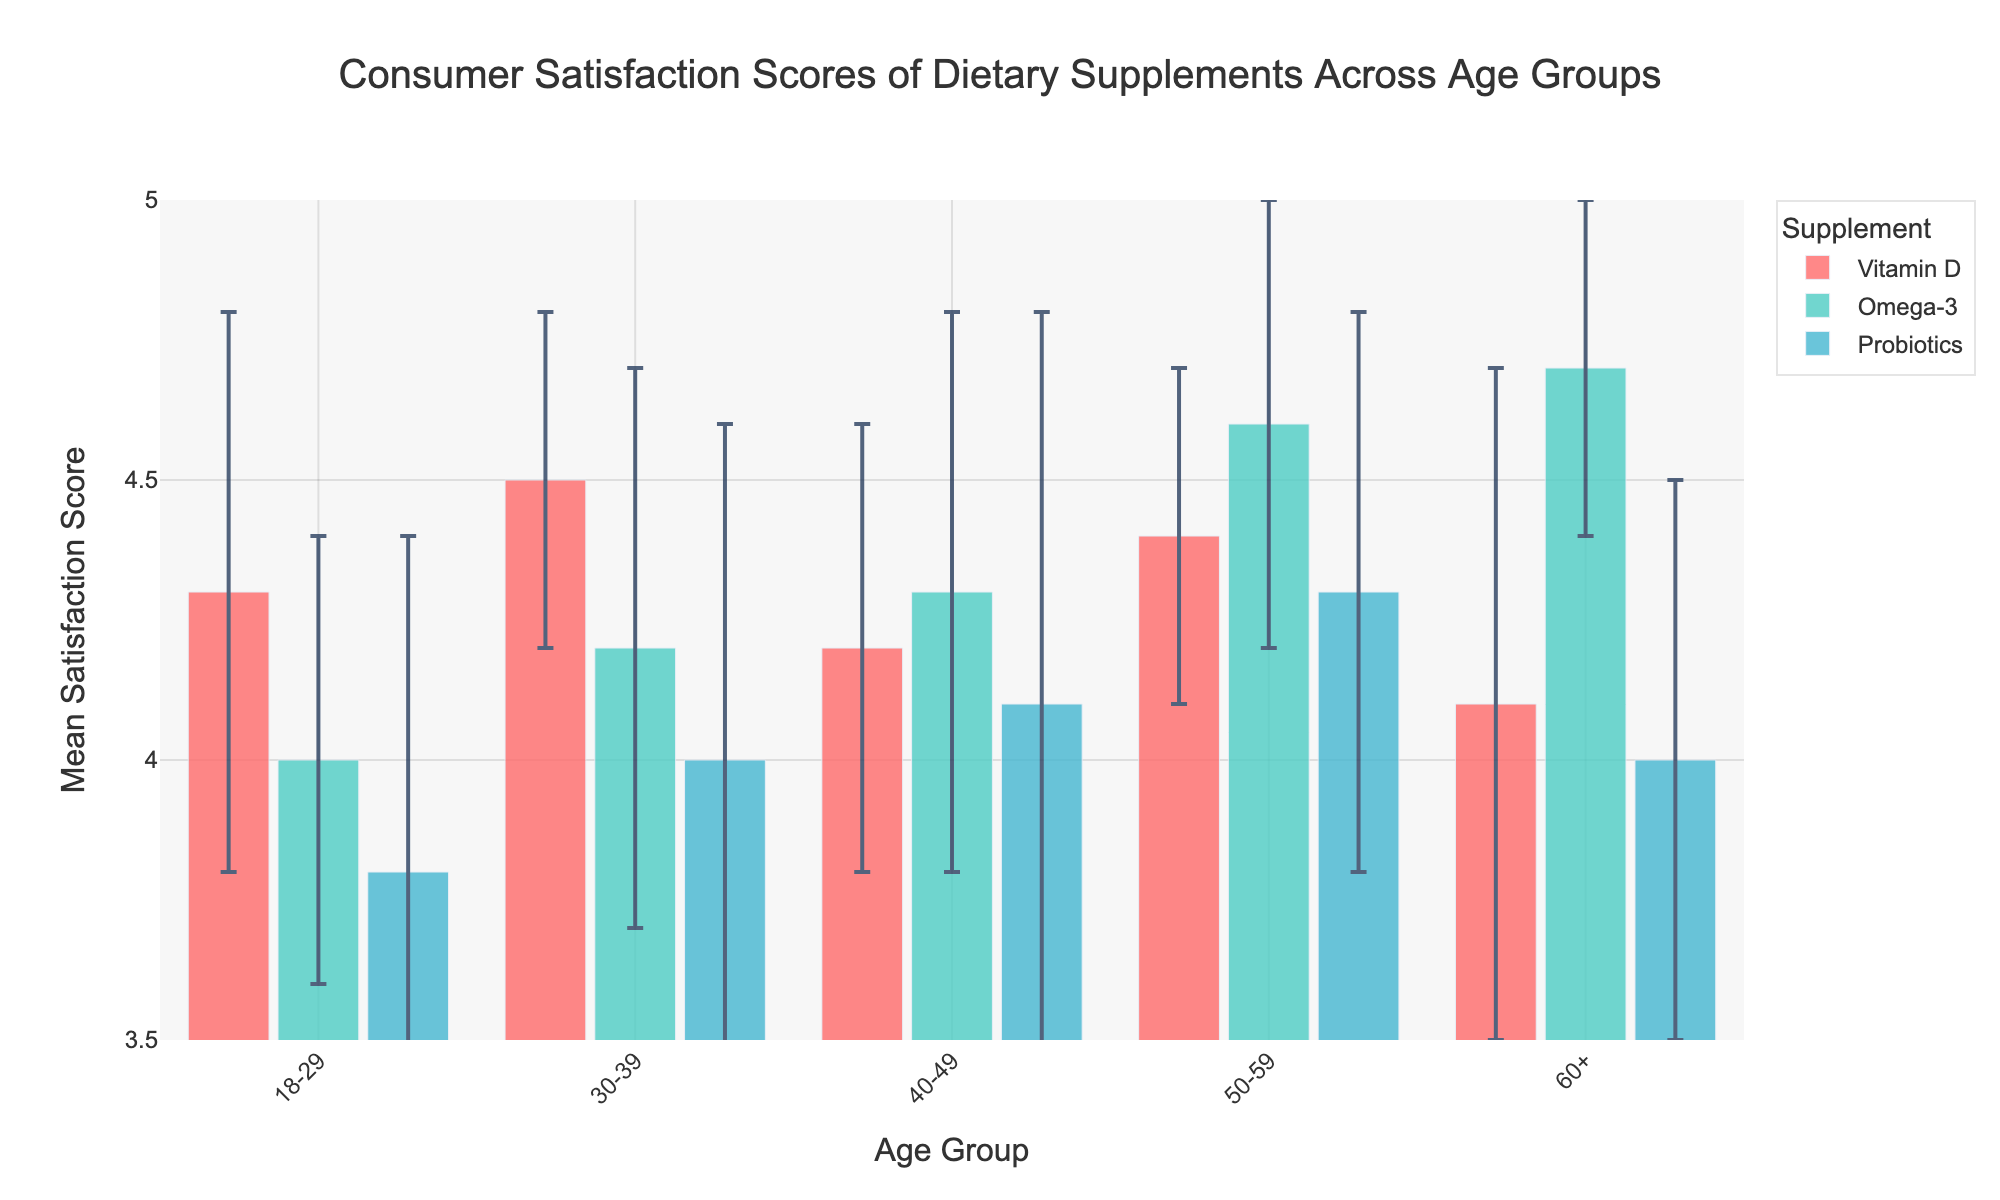What is the title of the figure? The title is displayed prominently at the top of the figure in larger font size. It summarizes the data presented in the plot.
Answer: Consumer Satisfaction Scores of Dietary Supplements Across Age Groups Which age group has the highest mean satisfaction score for Omega-3 supplements? The mean satisfaction scores for Omega-3 supplements are visible on the bars corresponding to each age group. The highest mean satisfaction score for Omega-3 is 4.7 in the 60+ age group.
Answer: 60+ What is the range of mean satisfaction scores for Vitamin D supplements? The range can be computed by finding the difference between the highest and lowest mean satisfaction scores for Vitamin D. The highest score is 4.5 in the 30-39 age group, and the lowest score is 4.1 in the 60+ age group, so the range is 4.5 - 4.1.
Answer: 0.4 Which age group exhibits the least variability in satisfaction scores for all supplements? Variability can be inferred from the standard deviations shown as error bars. The smallest error bars indicate the least variability. By comparing the error bars across all supplements, the 30-39 age group generally has the smallest error bars.
Answer: 30-39 How do the satisfaction scores for Probiotics vary across age groups? The mean satisfaction scores for Probiotics across age groups are: 3.8 (18-29), 4.0 (30-39), 4.1 (40-49), 4.3 (50-59), and 4.0 (60+). There is an increasing trend from 18-29 to 50-59, then a slight decrease in 60+.
Answer: Increasing, then decreasing Which dietary supplement has the most consistent satisfaction score across all age groups? Consistency can be assessed by examining the error bars (standard deviations) for each supplement across all age groups. Omega-3 has relatively small and consistent error bars across all age groups compared to the others.
Answer: Omega-3 Is there any age group where all three dietary supplements have almost the same mean satisfaction scores? By comparing the mean satisfaction scores for all three supplements within each age group, the 40-49 age group has very close scores: Vitamin D (4.2), Omega-3 (4.3), and Probiotics (4.1).
Answer: 40-49 What is the difference in mean satisfaction score between the youngest and oldest age groups for Omega-3 supplements? The mean satisfaction score for Omega-3 is 4.0 in the 18-29 age group and 4.7 in the 60+ age group. The difference is 4.7 - 4.0.
Answer: 0.7 